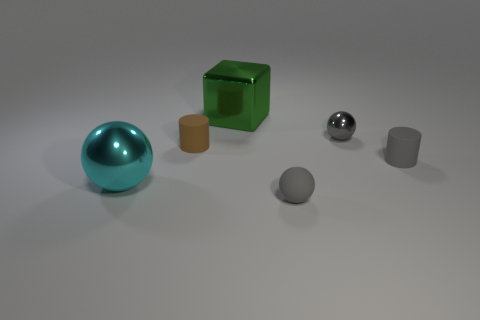What number of other small balls have the same color as the matte sphere?
Offer a terse response. 1. How many tiny things are blocks or gray spheres?
Give a very brief answer. 2. Is the tiny cylinder that is behind the gray matte cylinder made of the same material as the cyan ball?
Your answer should be very brief. No. There is a matte cylinder left of the metal cube; what color is it?
Keep it short and to the point. Brown. Are there any blocks that have the same size as the brown cylinder?
Offer a terse response. No. There is a brown object that is the same size as the gray cylinder; what is its material?
Give a very brief answer. Rubber. Is the size of the green object the same as the shiny sphere that is left of the large green shiny object?
Make the answer very short. Yes. There is a tiny brown cylinder on the left side of the gray metallic sphere; what material is it?
Provide a succinct answer. Rubber. Are there an equal number of tiny brown matte things that are right of the big green object and gray shiny spheres?
Ensure brevity in your answer.  No. Do the gray cylinder and the metallic cube have the same size?
Make the answer very short. No. 